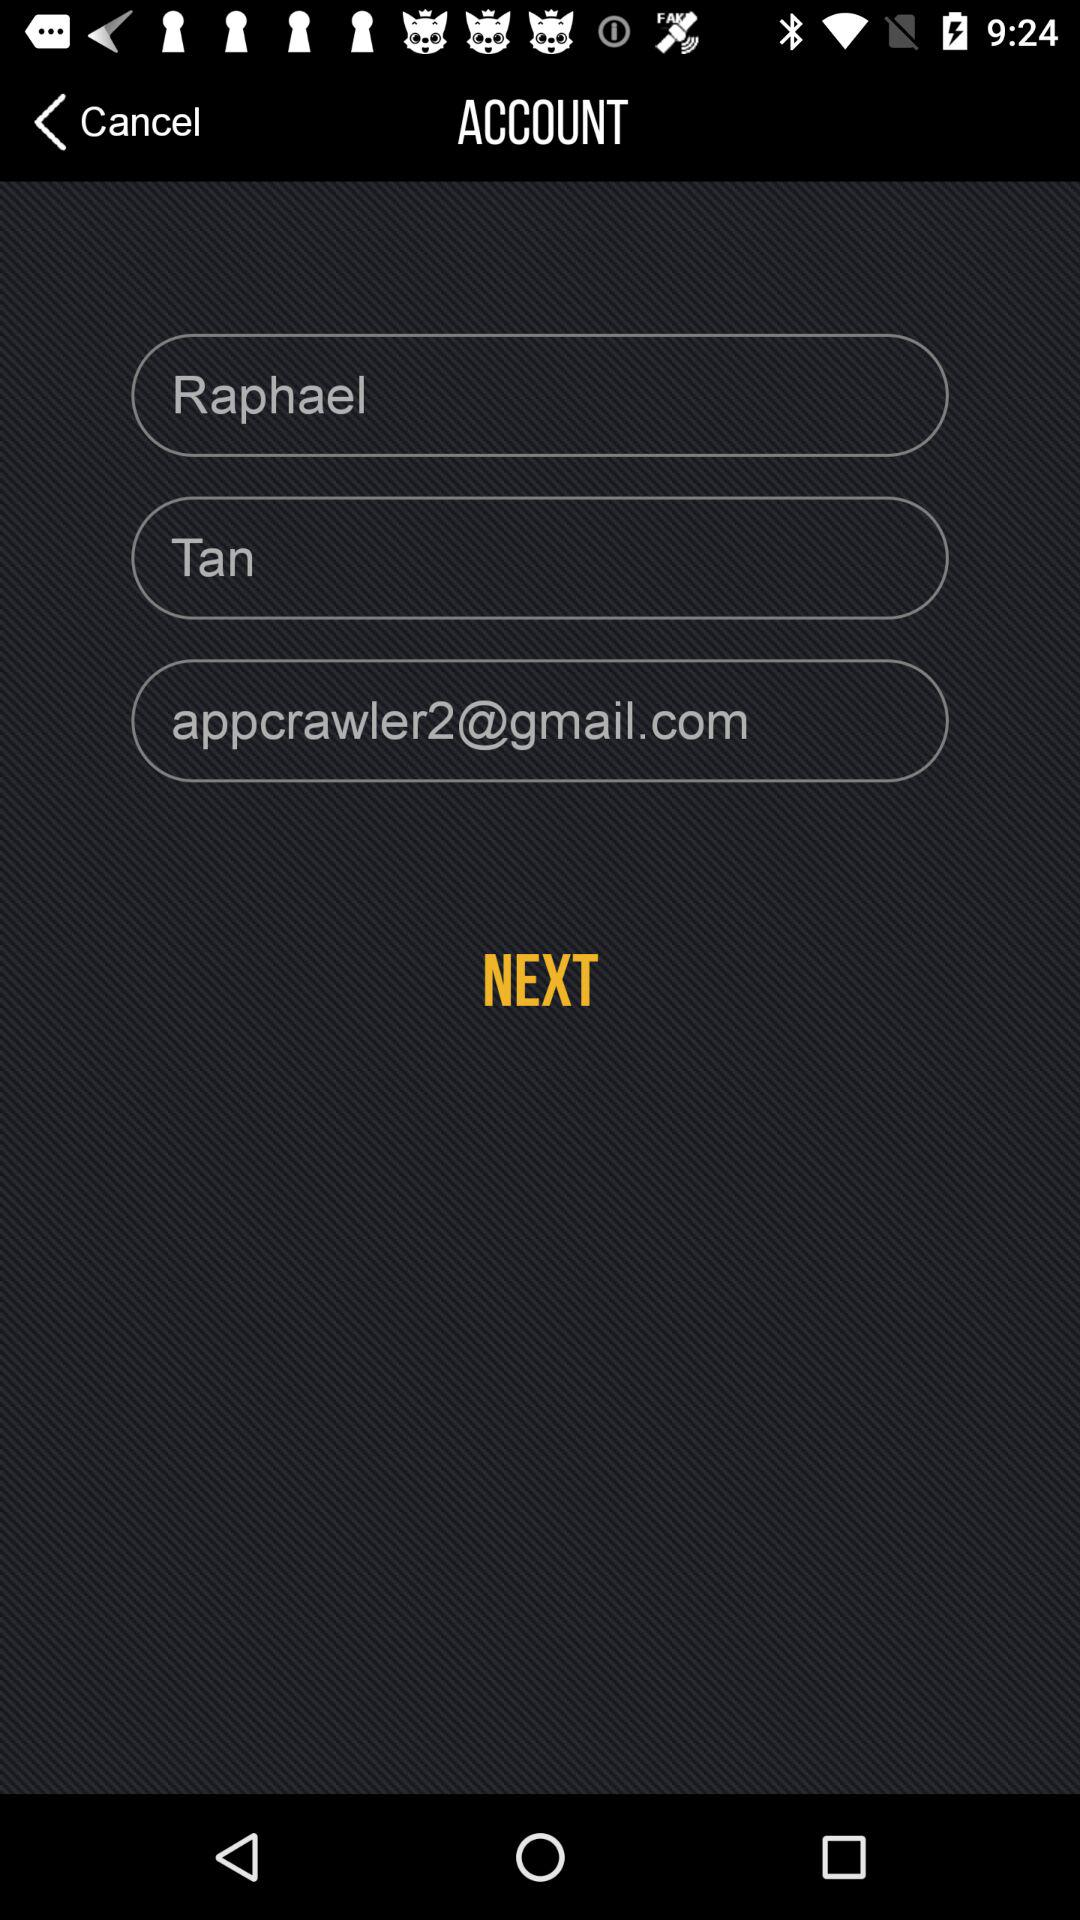What is the e-mail address? The email address is appcrawler2@gmail.com. 